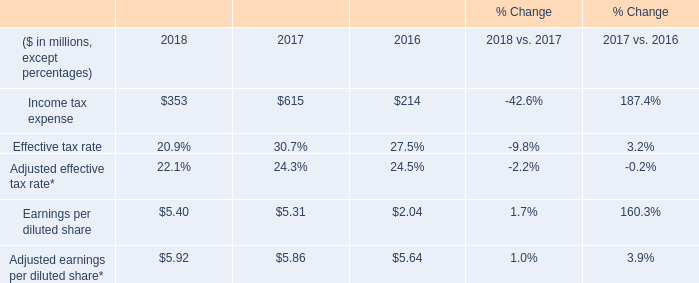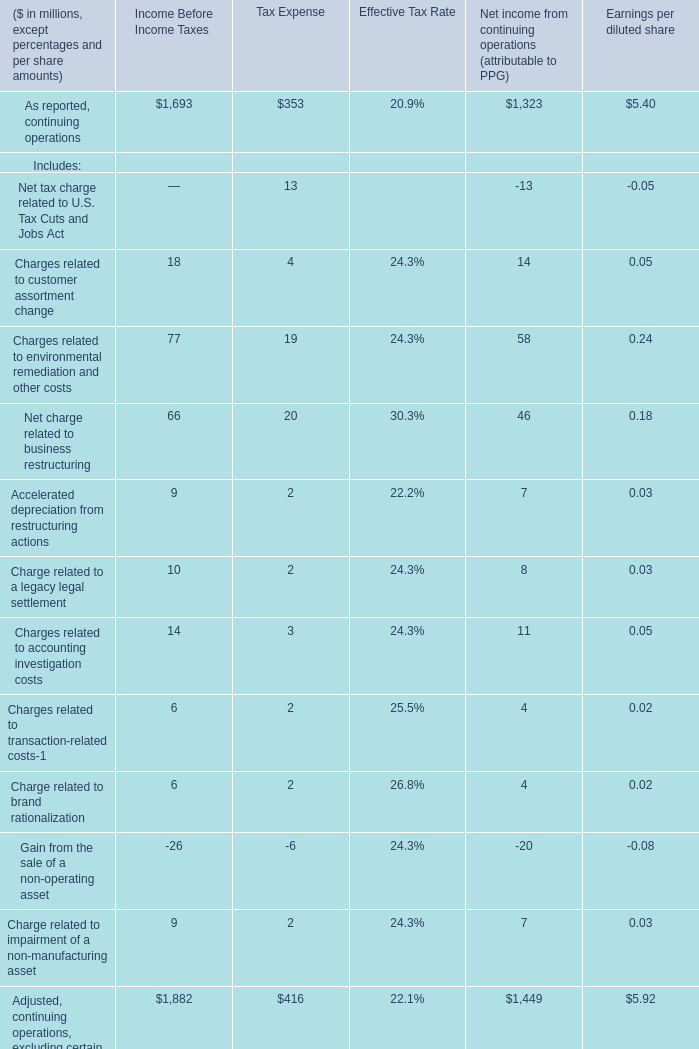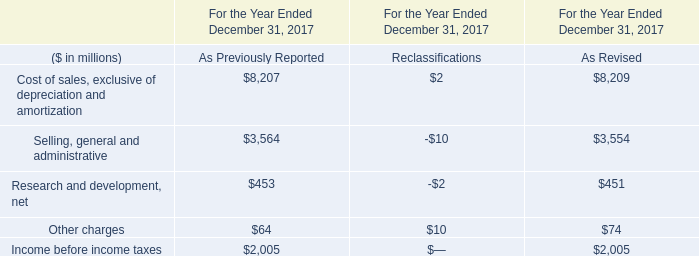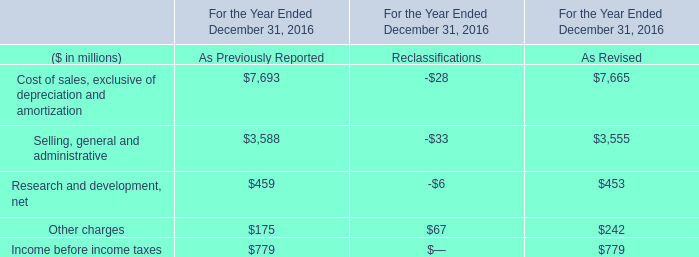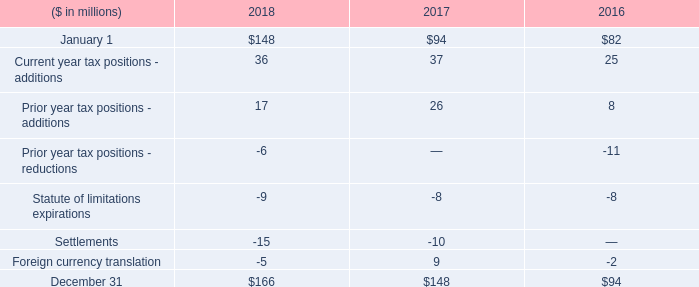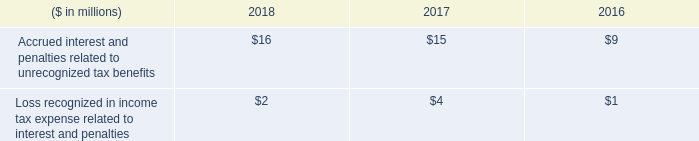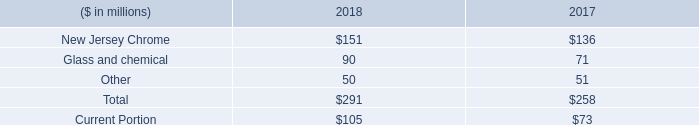are the 2018 environmental reserves greater than asbestos-related claim reserves? 
Computations: (180 + 291)
Answer: 471.0. 